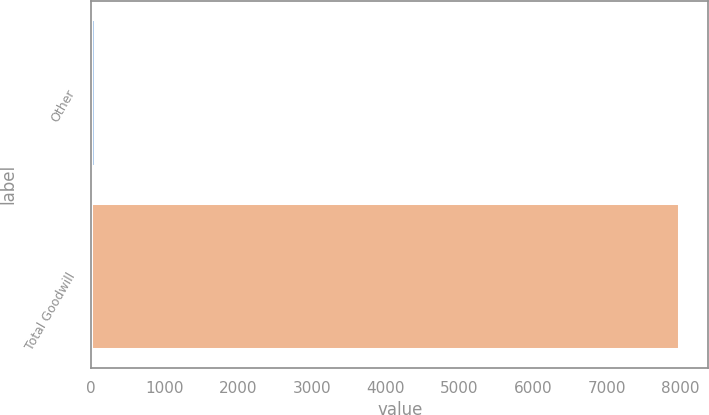Convert chart to OTSL. <chart><loc_0><loc_0><loc_500><loc_500><bar_chart><fcel>Other<fcel>Total Goodwill<nl><fcel>50<fcel>7983.6<nl></chart> 